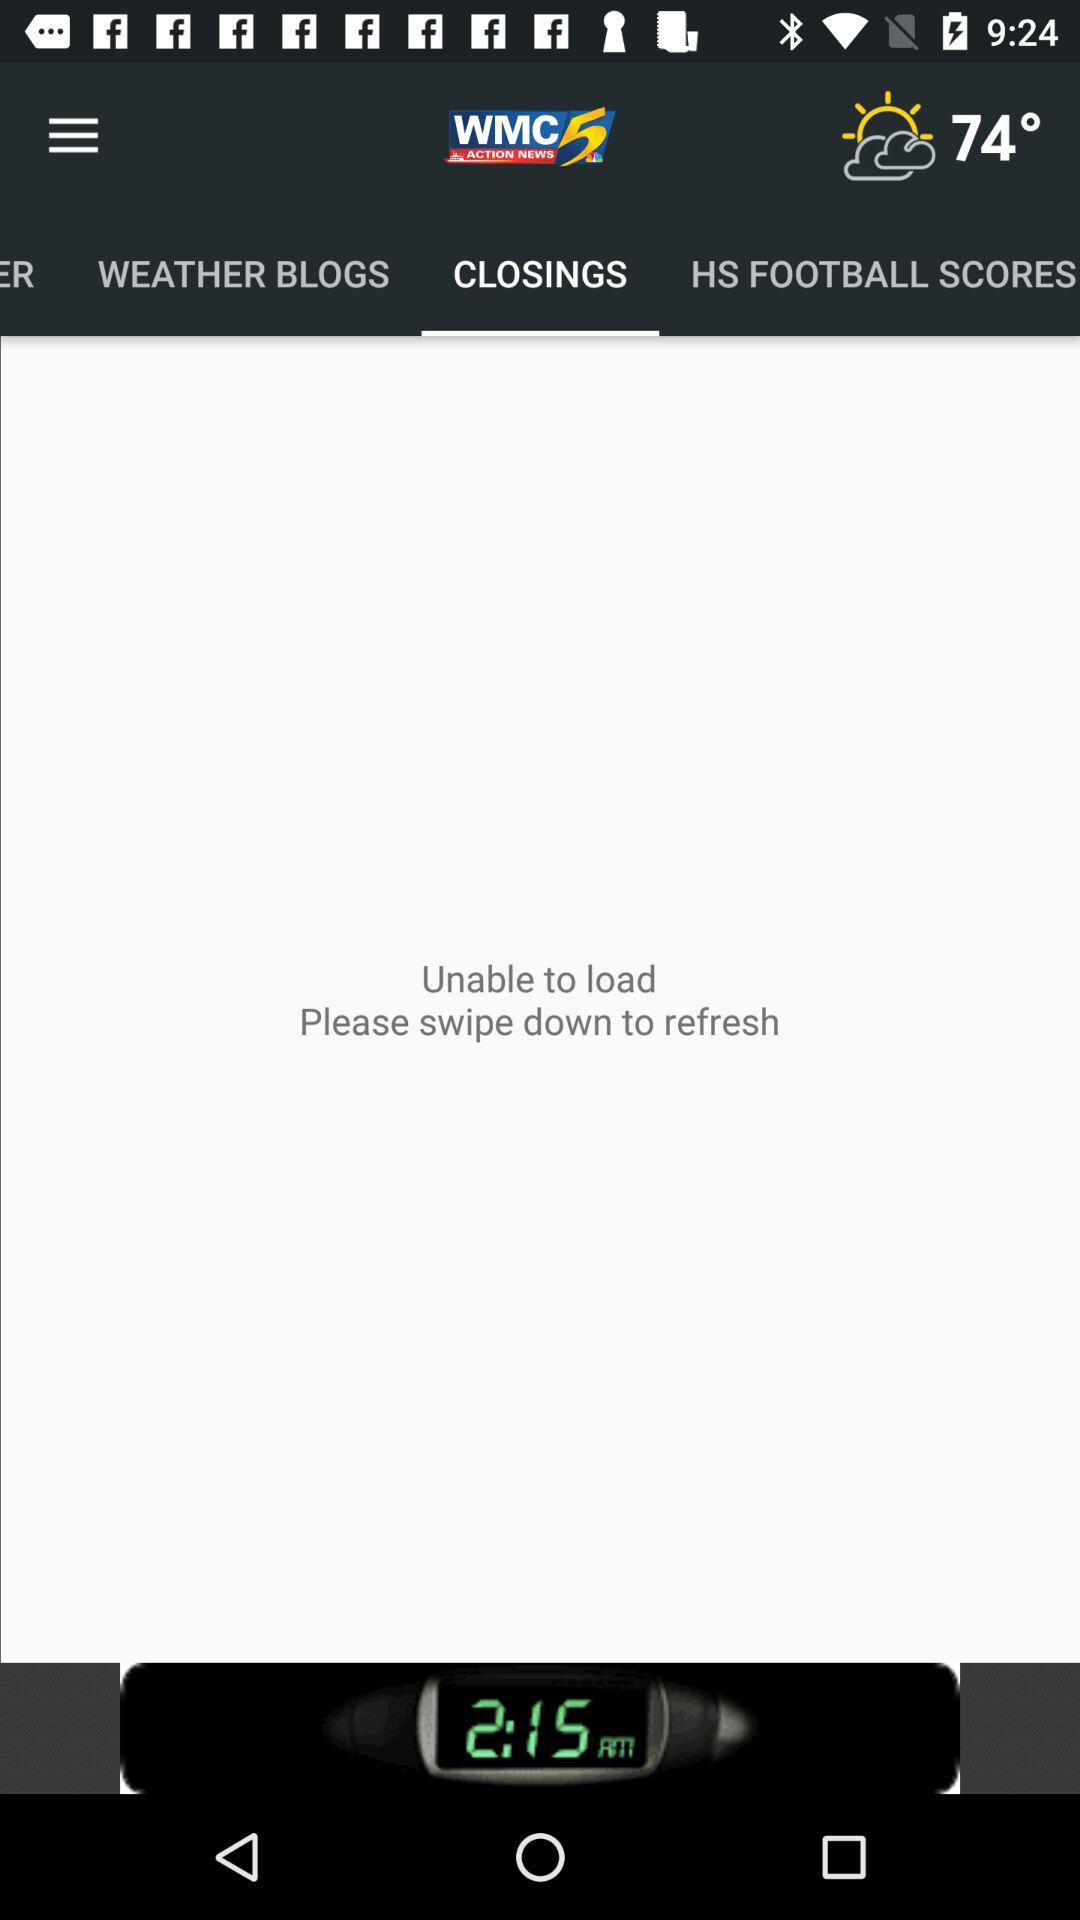Which tab is selected? The selected tab is "CLOSINGS". 